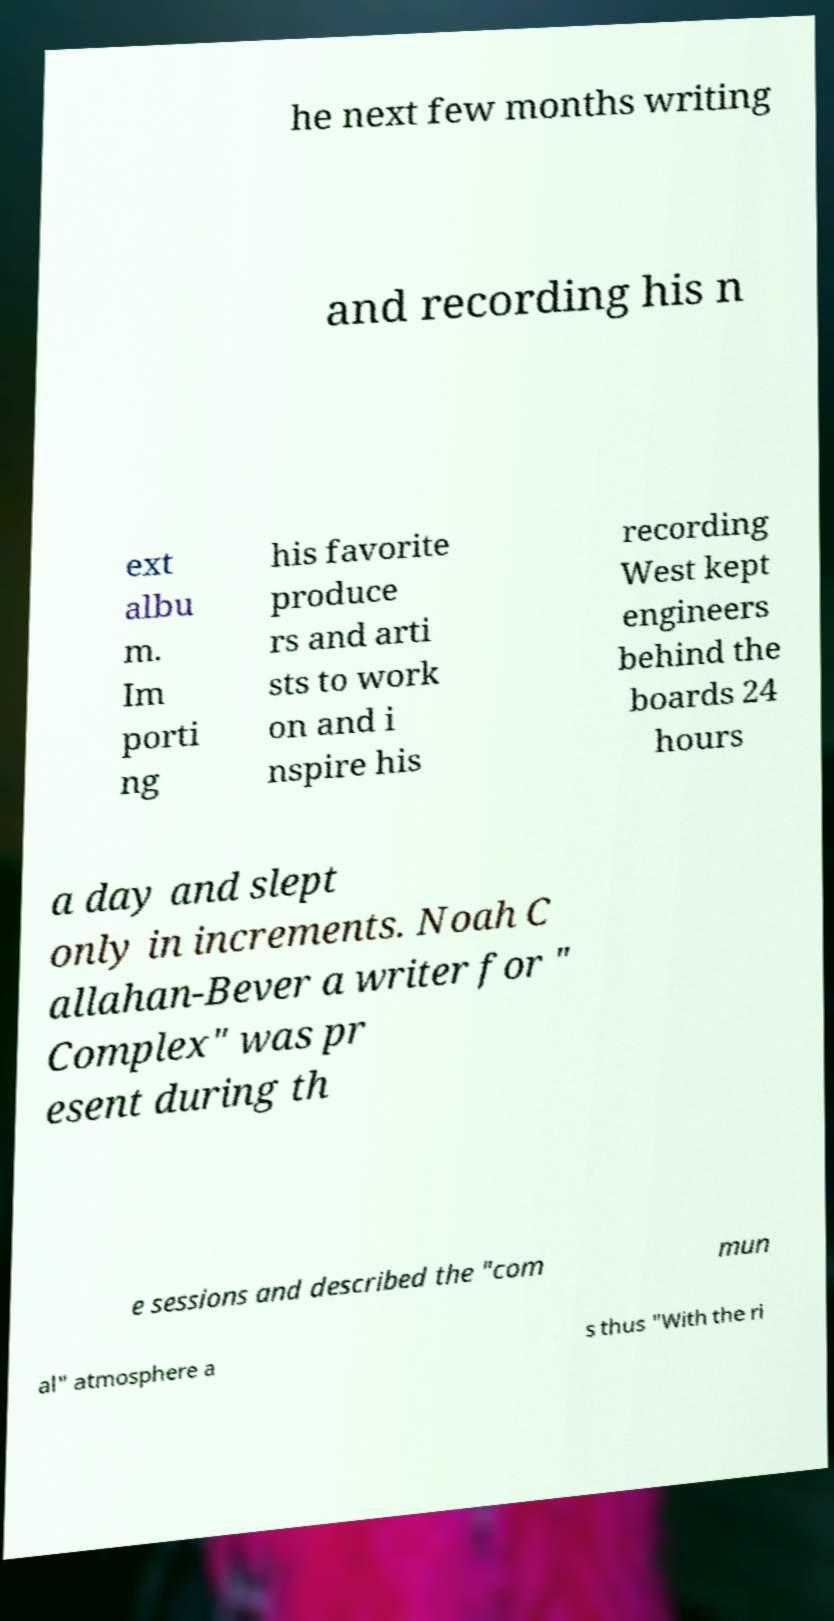What messages or text are displayed in this image? I need them in a readable, typed format. he next few months writing and recording his n ext albu m. Im porti ng his favorite produce rs and arti sts to work on and i nspire his recording West kept engineers behind the boards 24 hours a day and slept only in increments. Noah C allahan-Bever a writer for " Complex" was pr esent during th e sessions and described the "com mun al" atmosphere a s thus "With the ri 